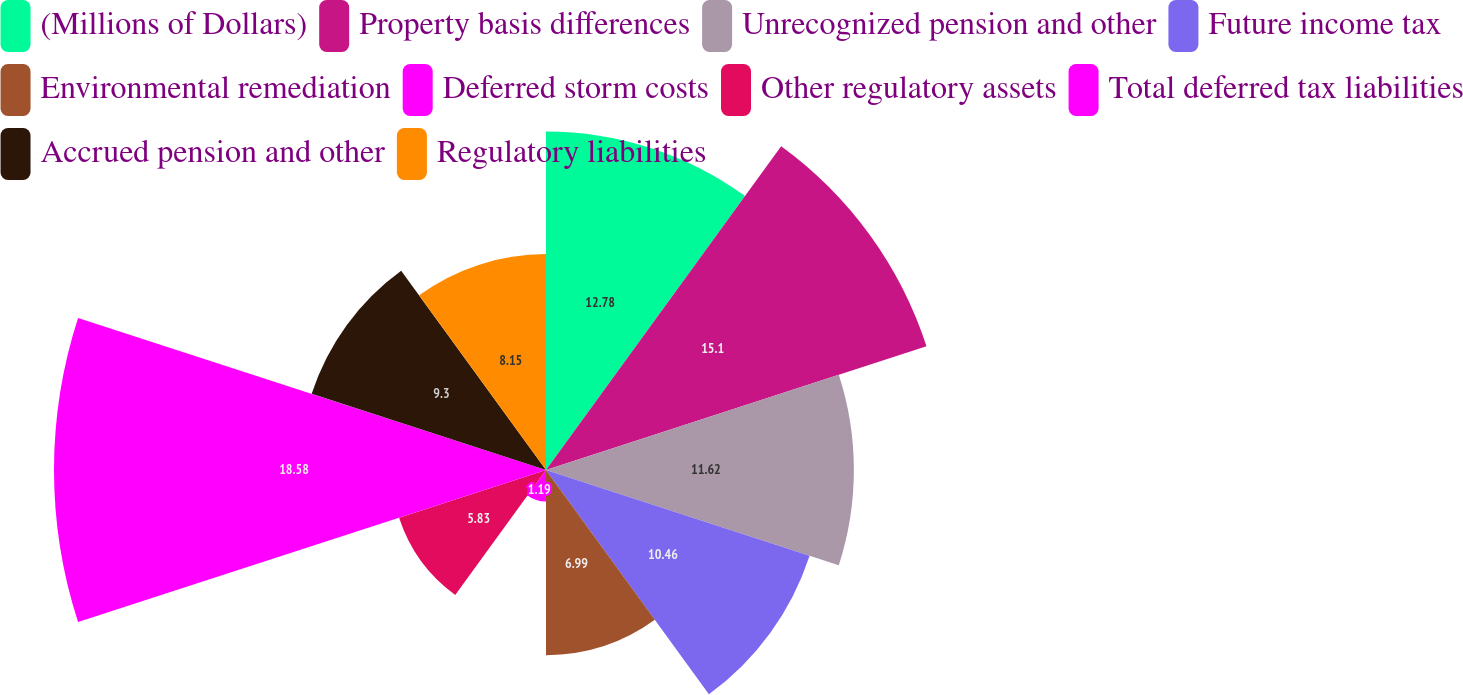Convert chart. <chart><loc_0><loc_0><loc_500><loc_500><pie_chart><fcel>(Millions of Dollars)<fcel>Property basis differences<fcel>Unrecognized pension and other<fcel>Future income tax<fcel>Environmental remediation<fcel>Deferred storm costs<fcel>Other regulatory assets<fcel>Total deferred tax liabilities<fcel>Accrued pension and other<fcel>Regulatory liabilities<nl><fcel>12.78%<fcel>15.1%<fcel>11.62%<fcel>10.46%<fcel>6.99%<fcel>1.19%<fcel>5.83%<fcel>18.57%<fcel>9.3%<fcel>8.15%<nl></chart> 